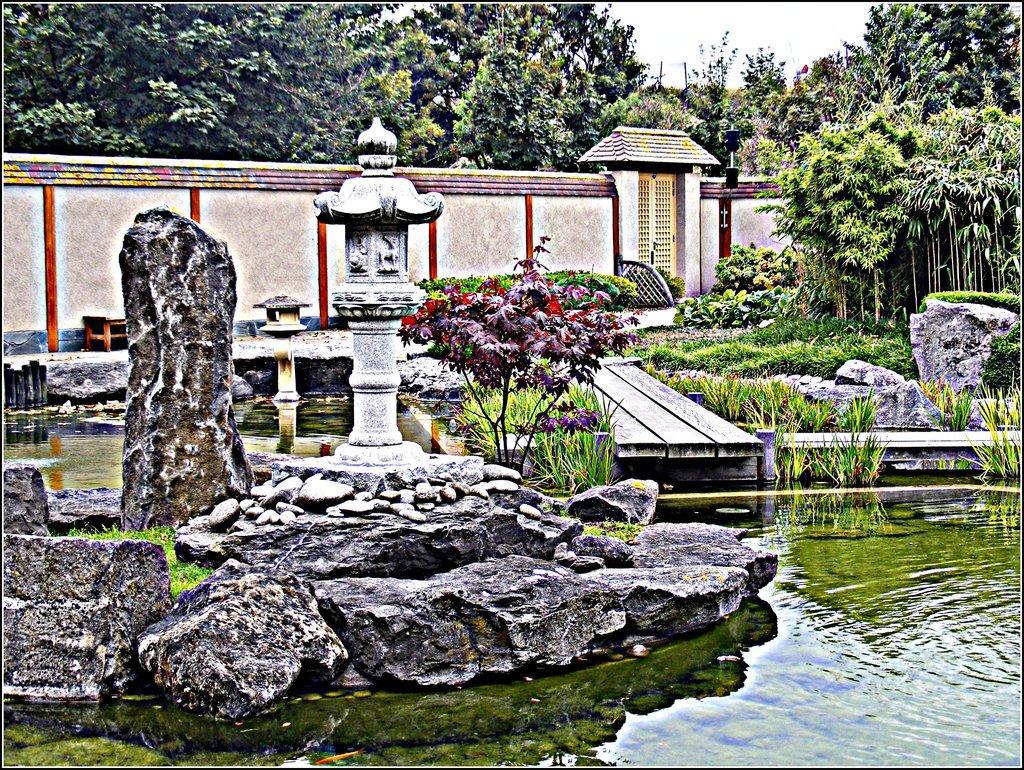Could you give a brief overview of what you see in this image? In this image we can see stone sculptures placed in a pond. In the background we can see a wall ,door ,group of trees and sky. 